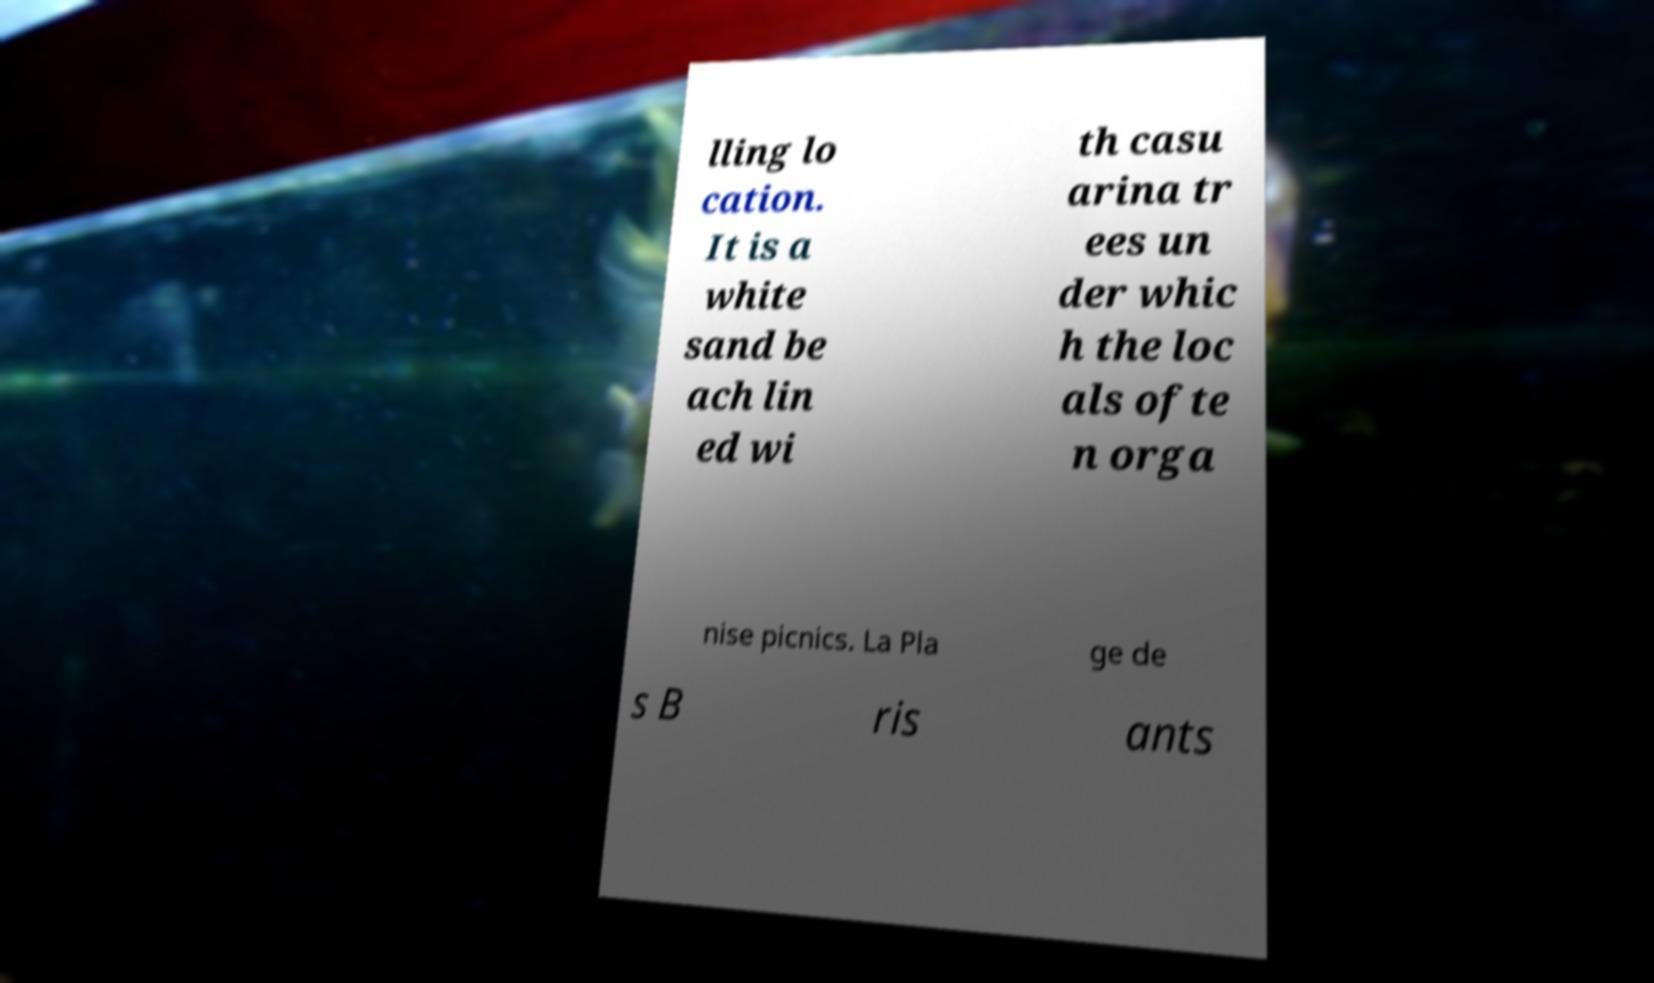What messages or text are displayed in this image? I need them in a readable, typed format. lling lo cation. It is a white sand be ach lin ed wi th casu arina tr ees un der whic h the loc als ofte n orga nise picnics. La Pla ge de s B ris ants 